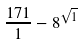<formula> <loc_0><loc_0><loc_500><loc_500>\frac { 1 7 1 } { 1 } - 8 ^ { \sqrt { 1 } }</formula> 